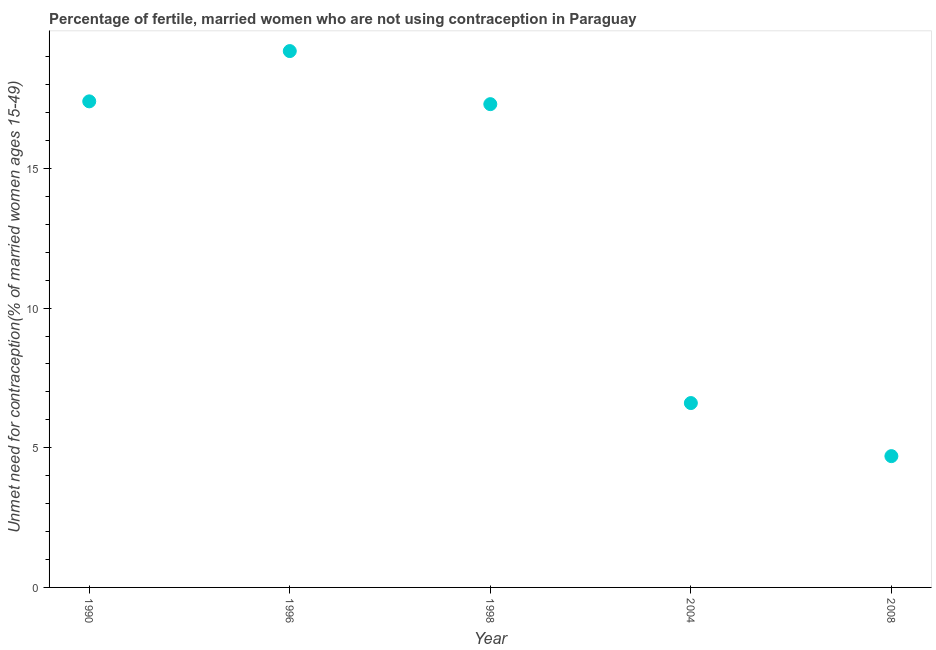What is the number of married women who are not using contraception in 1996?
Give a very brief answer. 19.2. Across all years, what is the maximum number of married women who are not using contraception?
Provide a short and direct response. 19.2. Across all years, what is the minimum number of married women who are not using contraception?
Your answer should be compact. 4.7. What is the sum of the number of married women who are not using contraception?
Your answer should be compact. 65.2. What is the difference between the number of married women who are not using contraception in 1996 and 2004?
Your answer should be very brief. 12.6. What is the average number of married women who are not using contraception per year?
Offer a terse response. 13.04. In how many years, is the number of married women who are not using contraception greater than 2 %?
Provide a short and direct response. 5. What is the ratio of the number of married women who are not using contraception in 1990 to that in 2008?
Provide a short and direct response. 3.7. Is the difference between the number of married women who are not using contraception in 1996 and 2008 greater than the difference between any two years?
Keep it short and to the point. Yes. What is the difference between the highest and the second highest number of married women who are not using contraception?
Offer a very short reply. 1.8. Is the sum of the number of married women who are not using contraception in 1996 and 2004 greater than the maximum number of married women who are not using contraception across all years?
Your response must be concise. Yes. What is the difference between the highest and the lowest number of married women who are not using contraception?
Offer a terse response. 14.5. Does the number of married women who are not using contraception monotonically increase over the years?
Give a very brief answer. No. How many dotlines are there?
Your answer should be very brief. 1. What is the difference between two consecutive major ticks on the Y-axis?
Keep it short and to the point. 5. Are the values on the major ticks of Y-axis written in scientific E-notation?
Provide a succinct answer. No. Does the graph contain any zero values?
Offer a terse response. No. Does the graph contain grids?
Your response must be concise. No. What is the title of the graph?
Your answer should be very brief. Percentage of fertile, married women who are not using contraception in Paraguay. What is the label or title of the X-axis?
Offer a terse response. Year. What is the label or title of the Y-axis?
Keep it short and to the point.  Unmet need for contraception(% of married women ages 15-49). What is the  Unmet need for contraception(% of married women ages 15-49) in 1990?
Provide a succinct answer. 17.4. What is the  Unmet need for contraception(% of married women ages 15-49) in 1996?
Your answer should be compact. 19.2. What is the  Unmet need for contraception(% of married women ages 15-49) in 2004?
Your answer should be compact. 6.6. What is the  Unmet need for contraception(% of married women ages 15-49) in 2008?
Give a very brief answer. 4.7. What is the difference between the  Unmet need for contraception(% of married women ages 15-49) in 1990 and 1996?
Provide a succinct answer. -1.8. What is the difference between the  Unmet need for contraception(% of married women ages 15-49) in 1990 and 1998?
Your answer should be very brief. 0.1. What is the difference between the  Unmet need for contraception(% of married women ages 15-49) in 1990 and 2008?
Provide a short and direct response. 12.7. What is the difference between the  Unmet need for contraception(% of married women ages 15-49) in 1996 and 2004?
Provide a succinct answer. 12.6. What is the difference between the  Unmet need for contraception(% of married women ages 15-49) in 1998 and 2004?
Offer a terse response. 10.7. What is the ratio of the  Unmet need for contraception(% of married women ages 15-49) in 1990 to that in 1996?
Provide a succinct answer. 0.91. What is the ratio of the  Unmet need for contraception(% of married women ages 15-49) in 1990 to that in 2004?
Ensure brevity in your answer.  2.64. What is the ratio of the  Unmet need for contraception(% of married women ages 15-49) in 1990 to that in 2008?
Give a very brief answer. 3.7. What is the ratio of the  Unmet need for contraception(% of married women ages 15-49) in 1996 to that in 1998?
Your response must be concise. 1.11. What is the ratio of the  Unmet need for contraception(% of married women ages 15-49) in 1996 to that in 2004?
Offer a terse response. 2.91. What is the ratio of the  Unmet need for contraception(% of married women ages 15-49) in 1996 to that in 2008?
Give a very brief answer. 4.08. What is the ratio of the  Unmet need for contraception(% of married women ages 15-49) in 1998 to that in 2004?
Ensure brevity in your answer.  2.62. What is the ratio of the  Unmet need for contraception(% of married women ages 15-49) in 1998 to that in 2008?
Provide a short and direct response. 3.68. What is the ratio of the  Unmet need for contraception(% of married women ages 15-49) in 2004 to that in 2008?
Your response must be concise. 1.4. 